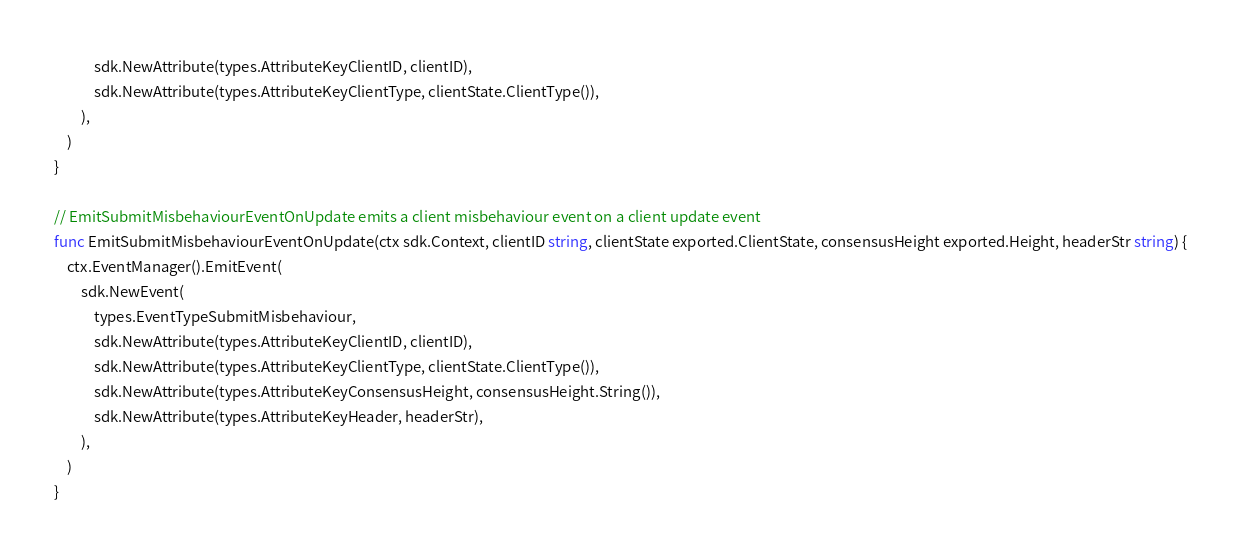<code> <loc_0><loc_0><loc_500><loc_500><_Go_>			sdk.NewAttribute(types.AttributeKeyClientID, clientID),
			sdk.NewAttribute(types.AttributeKeyClientType, clientState.ClientType()),
		),
	)
}

// EmitSubmitMisbehaviourEventOnUpdate emits a client misbehaviour event on a client update event
func EmitSubmitMisbehaviourEventOnUpdate(ctx sdk.Context, clientID string, clientState exported.ClientState, consensusHeight exported.Height, headerStr string) {
	ctx.EventManager().EmitEvent(
		sdk.NewEvent(
			types.EventTypeSubmitMisbehaviour,
			sdk.NewAttribute(types.AttributeKeyClientID, clientID),
			sdk.NewAttribute(types.AttributeKeyClientType, clientState.ClientType()),
			sdk.NewAttribute(types.AttributeKeyConsensusHeight, consensusHeight.String()),
			sdk.NewAttribute(types.AttributeKeyHeader, headerStr),
		),
	)
}
</code> 